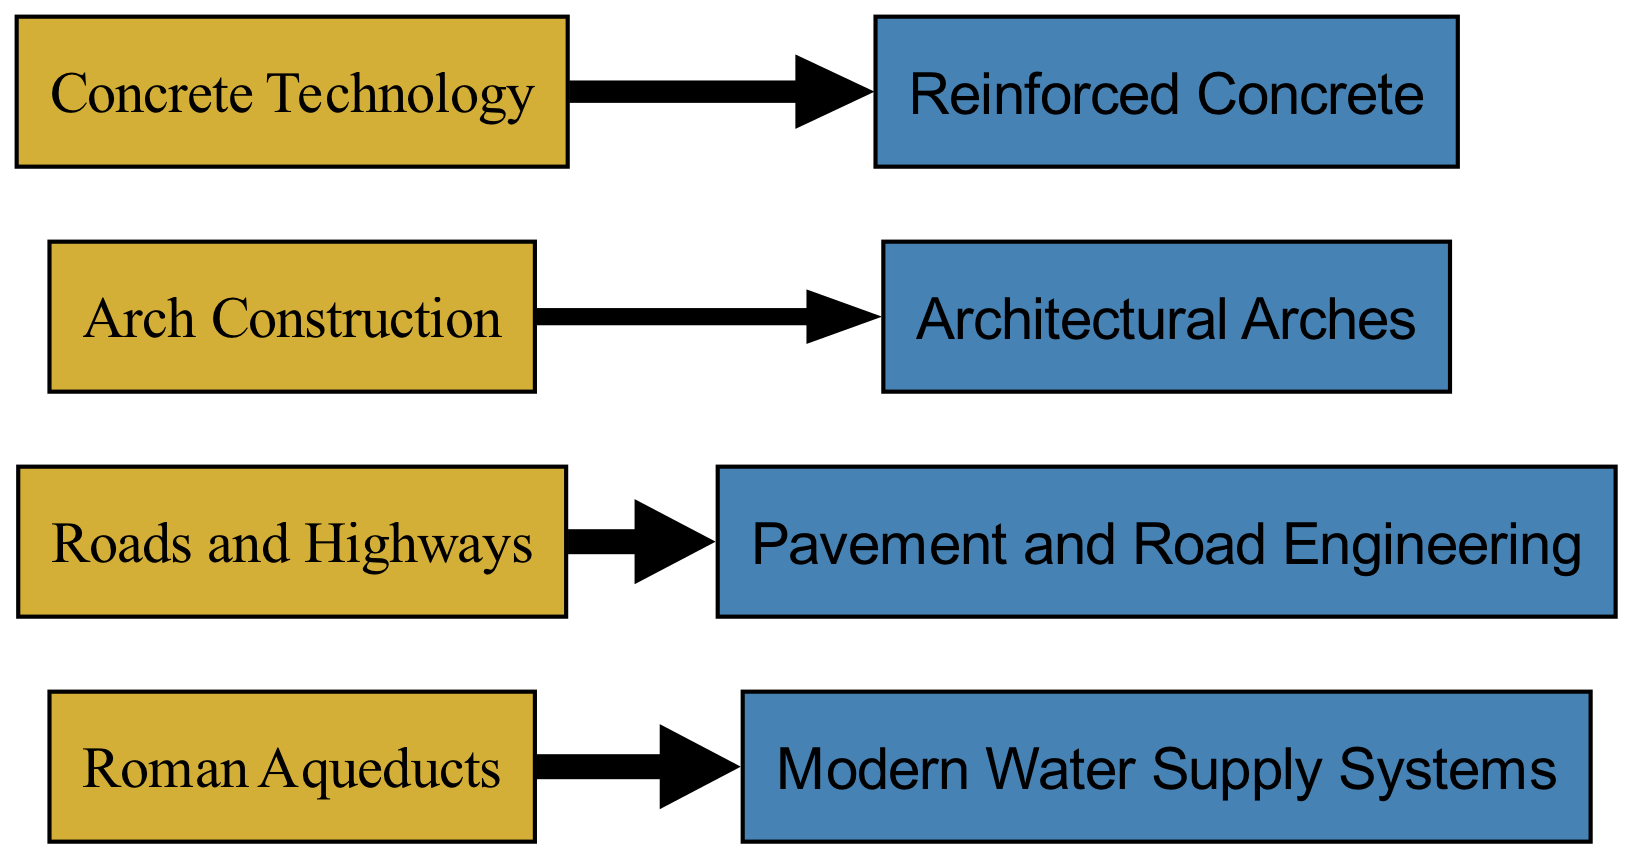What are the four ancient innovations depicted in the diagram? The diagram lists four ancient innovations in the nodes: "Roman Aqueducts," "Roads and Highways," "Arch Construction," and "Concrete Technology."
Answer: Roman Aqueducts, Roads and Highways, Arch Construction, Concrete Technology How many modern infrastructure applications are shown? There are four modern applications shown in the nodes: "Modern Water Supply Systems," "Pavement and Road Engineering," "Architectural Arches," and "Reinforced Concrete." Therefore, the count of modern applications is four.
Answer: Four Which ancient innovation has the highest flow value to its corresponding modern application? The flow from "Roman Aqueducts" to "Modern Water Supply Systems" has a value of 8, which is higher than the others. Thus, it has the highest flow value.
Answer: Roman Aqueducts What is the value of the flow from "Roads and Highways"? The flow from "Roads and Highways" to "Pavement and Road Engineering" has a value of 8. This means that it represents the full value and effort relating to that connection.
Answer: 8 Which modern application is associated with "Concrete Technology"? The flow indicates that "Concrete Technology" connects to "Reinforced Concrete," showing the relationship between the ancient technique and its modern use.
Answer: Reinforced Concrete Which ancient innovation connects to "Architectural Arches"? The connection reveals that "Arch Construction" is the ancient innovation linking to "Architectural Arches," illustrating its influence on modern architecture.
Answer: Arch Construction How many edges are represented in the diagram? There are four links connecting the nodes, which can be determined by counting the edges defined in the relationships between ancient and modern applications.
Answer: Four Which ancient innovation flows to the least modern applications? The ancient innovation "Arch Construction" flows to only one modern application, which is "Architectural Arches." This indicates a more specialized influence compared to the others.
Answer: Arch Construction 